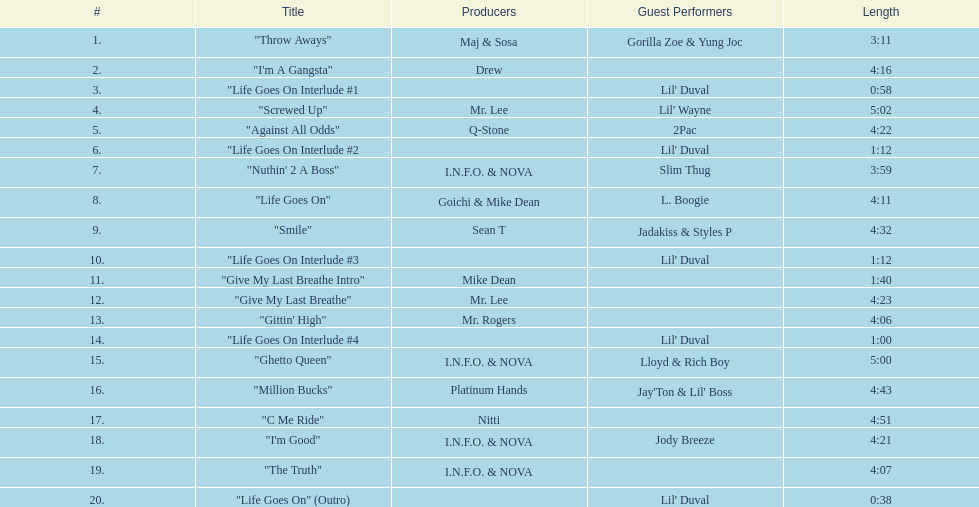Which continuous tracks on this album have the same producer(s)? "I'm Good", "The Truth". 